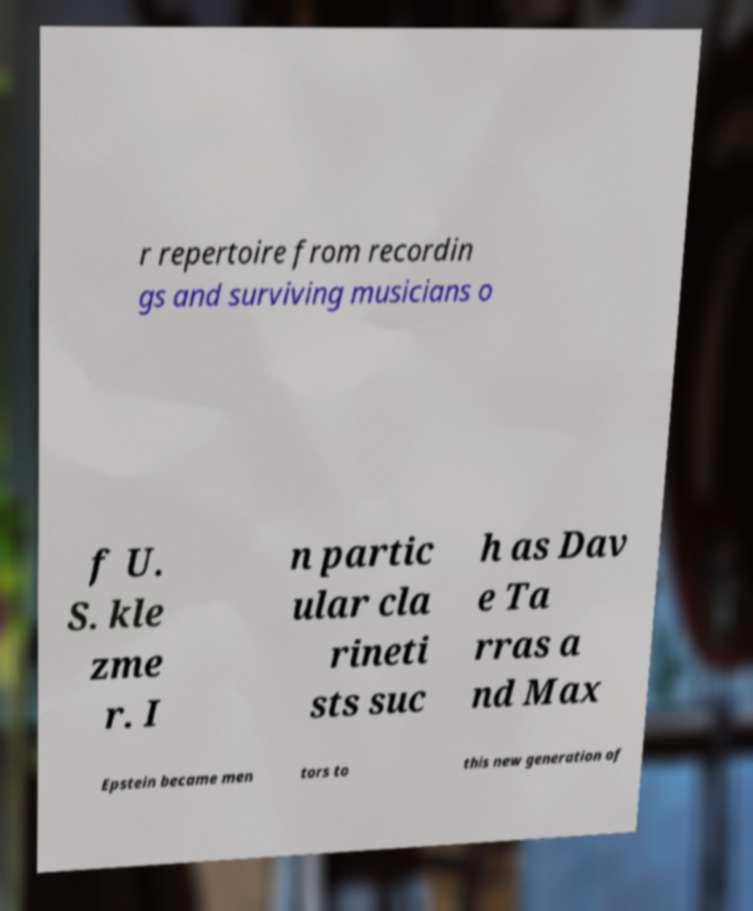Please read and relay the text visible in this image. What does it say? r repertoire from recordin gs and surviving musicians o f U. S. kle zme r. I n partic ular cla rineti sts suc h as Dav e Ta rras a nd Max Epstein became men tors to this new generation of 